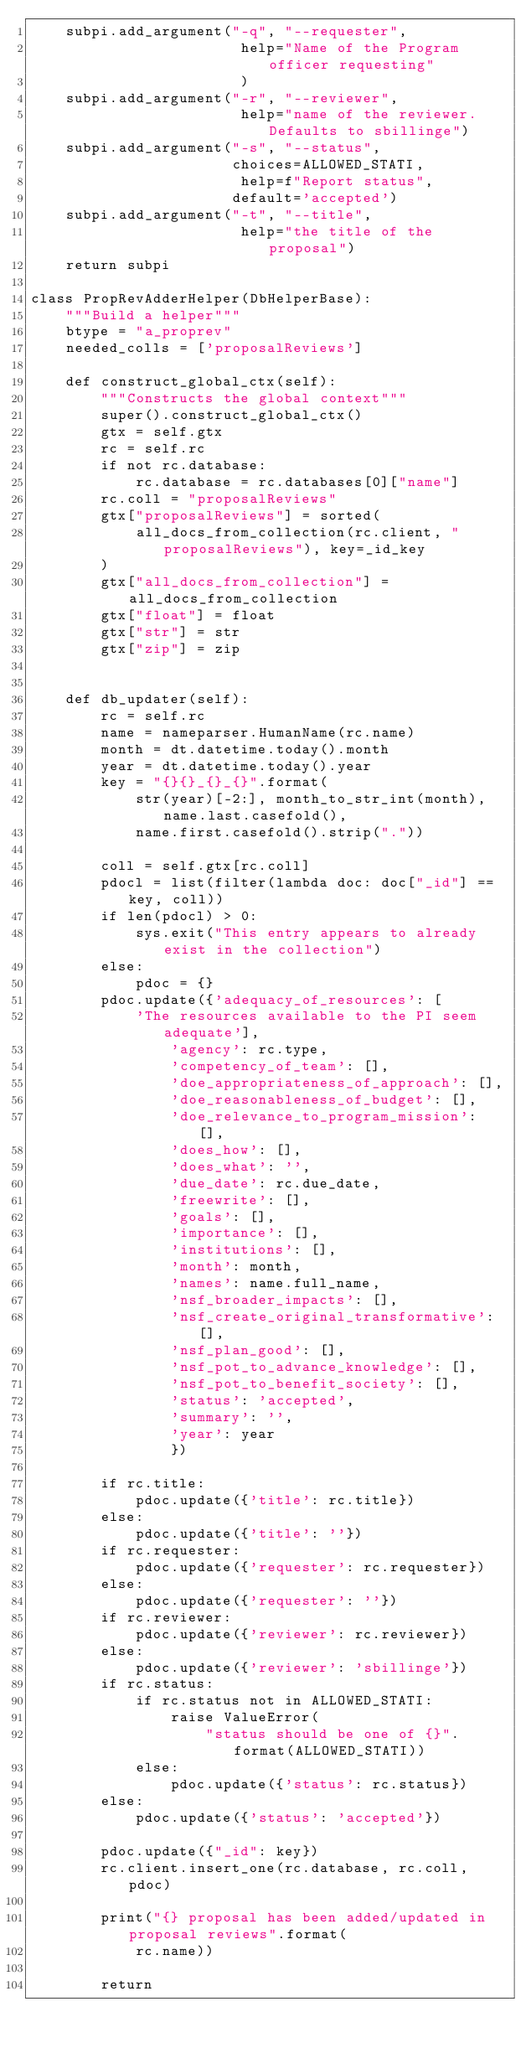Convert code to text. <code><loc_0><loc_0><loc_500><loc_500><_Python_>    subpi.add_argument("-q", "--requester",
                        help="Name of the Program officer requesting"
                        )
    subpi.add_argument("-r", "--reviewer",
                        help="name of the reviewer.  Defaults to sbillinge")
    subpi.add_argument("-s", "--status",
                       choices=ALLOWED_STATI,
                        help=f"Report status",
                       default='accepted')
    subpi.add_argument("-t", "--title",
                        help="the title of the proposal")
    return subpi

class PropRevAdderHelper(DbHelperBase):
    """Build a helper"""
    btype = "a_proprev"
    needed_colls = ['proposalReviews']

    def construct_global_ctx(self):
        """Constructs the global context"""
        super().construct_global_ctx()
        gtx = self.gtx
        rc = self.rc
        if not rc.database:
            rc.database = rc.databases[0]["name"]
        rc.coll = "proposalReviews"
        gtx["proposalReviews"] = sorted(
            all_docs_from_collection(rc.client, "proposalReviews"), key=_id_key
        )
        gtx["all_docs_from_collection"] = all_docs_from_collection
        gtx["float"] = float
        gtx["str"] = str
        gtx["zip"] = zip


    def db_updater(self):
        rc = self.rc
        name = nameparser.HumanName(rc.name)
        month = dt.datetime.today().month
        year = dt.datetime.today().year
        key = "{}{}_{}_{}".format(
            str(year)[-2:], month_to_str_int(month), name.last.casefold(),
            name.first.casefold().strip("."))

        coll = self.gtx[rc.coll]
        pdocl = list(filter(lambda doc: doc["_id"] == key, coll))
        if len(pdocl) > 0:
            sys.exit("This entry appears to already exist in the collection")
        else:
            pdoc = {}
        pdoc.update({'adequacy_of_resources': [
            'The resources available to the PI seem adequate'],
                'agency': rc.type,
                'competency_of_team': [],
                'doe_appropriateness_of_approach': [],
                'doe_reasonableness_of_budget': [],
                'doe_relevance_to_program_mission': [],
                'does_how': [],
                'does_what': '',
                'due_date': rc.due_date,
                'freewrite': [],
                'goals': [],
                'importance': [],
                'institutions': [],
                'month': month,
                'names': name.full_name,
                'nsf_broader_impacts': [],
                'nsf_create_original_transformative': [],
                'nsf_plan_good': [],
                'nsf_pot_to_advance_knowledge': [],
                'nsf_pot_to_benefit_society': [],
                'status': 'accepted',
                'summary': '',
                'year': year
                })

        if rc.title:
            pdoc.update({'title': rc.title})
        else:
            pdoc.update({'title': ''})
        if rc.requester:
            pdoc.update({'requester': rc.requester})
        else:
            pdoc.update({'requester': ''})
        if rc.reviewer:
            pdoc.update({'reviewer': rc.reviewer})
        else:
            pdoc.update({'reviewer': 'sbillinge'})
        if rc.status:
            if rc.status not in ALLOWED_STATI:
                raise ValueError(
                    "status should be one of {}".format(ALLOWED_STATI))
            else:
                pdoc.update({'status': rc.status})
        else:
            pdoc.update({'status': 'accepted'})

        pdoc.update({"_id": key})
        rc.client.insert_one(rc.database, rc.coll, pdoc)

        print("{} proposal has been added/updated in proposal reviews".format(
            rc.name))

        return

</code> 